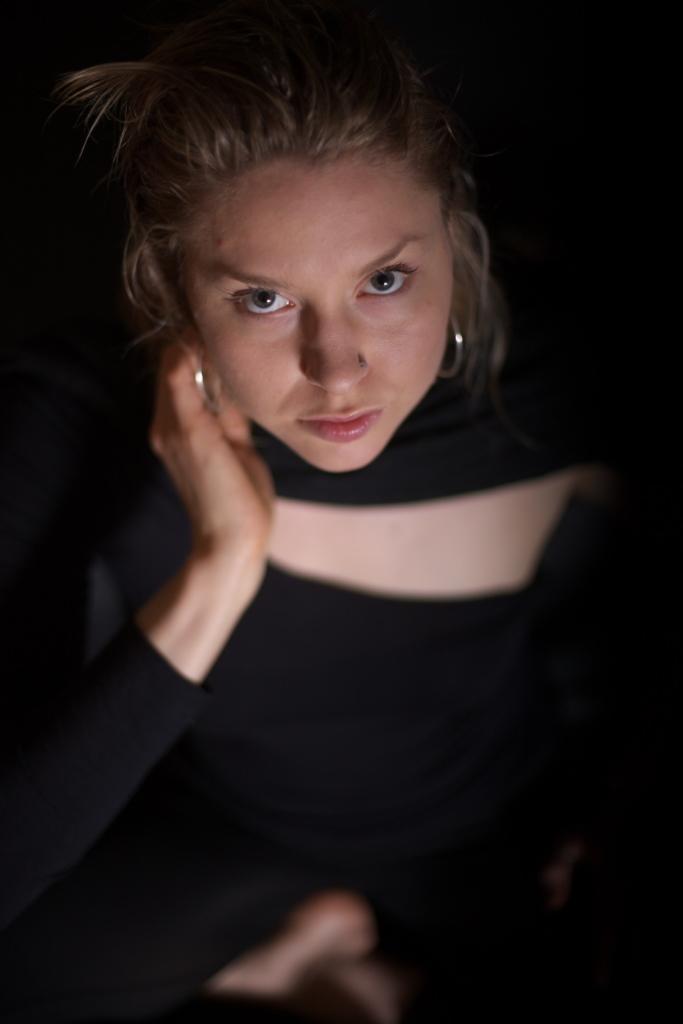Describe this image in one or two sentences. In this image we can see a lady wearing black color dress and silver color earrings. 